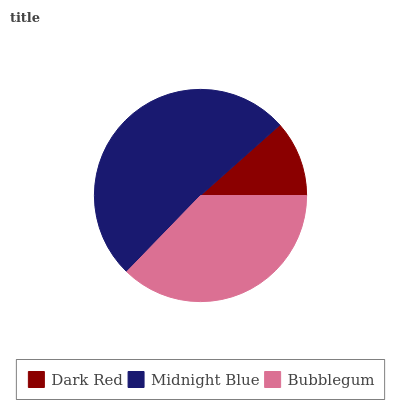Is Dark Red the minimum?
Answer yes or no. Yes. Is Midnight Blue the maximum?
Answer yes or no. Yes. Is Bubblegum the minimum?
Answer yes or no. No. Is Bubblegum the maximum?
Answer yes or no. No. Is Midnight Blue greater than Bubblegum?
Answer yes or no. Yes. Is Bubblegum less than Midnight Blue?
Answer yes or no. Yes. Is Bubblegum greater than Midnight Blue?
Answer yes or no. No. Is Midnight Blue less than Bubblegum?
Answer yes or no. No. Is Bubblegum the high median?
Answer yes or no. Yes. Is Bubblegum the low median?
Answer yes or no. Yes. Is Midnight Blue the high median?
Answer yes or no. No. Is Midnight Blue the low median?
Answer yes or no. No. 